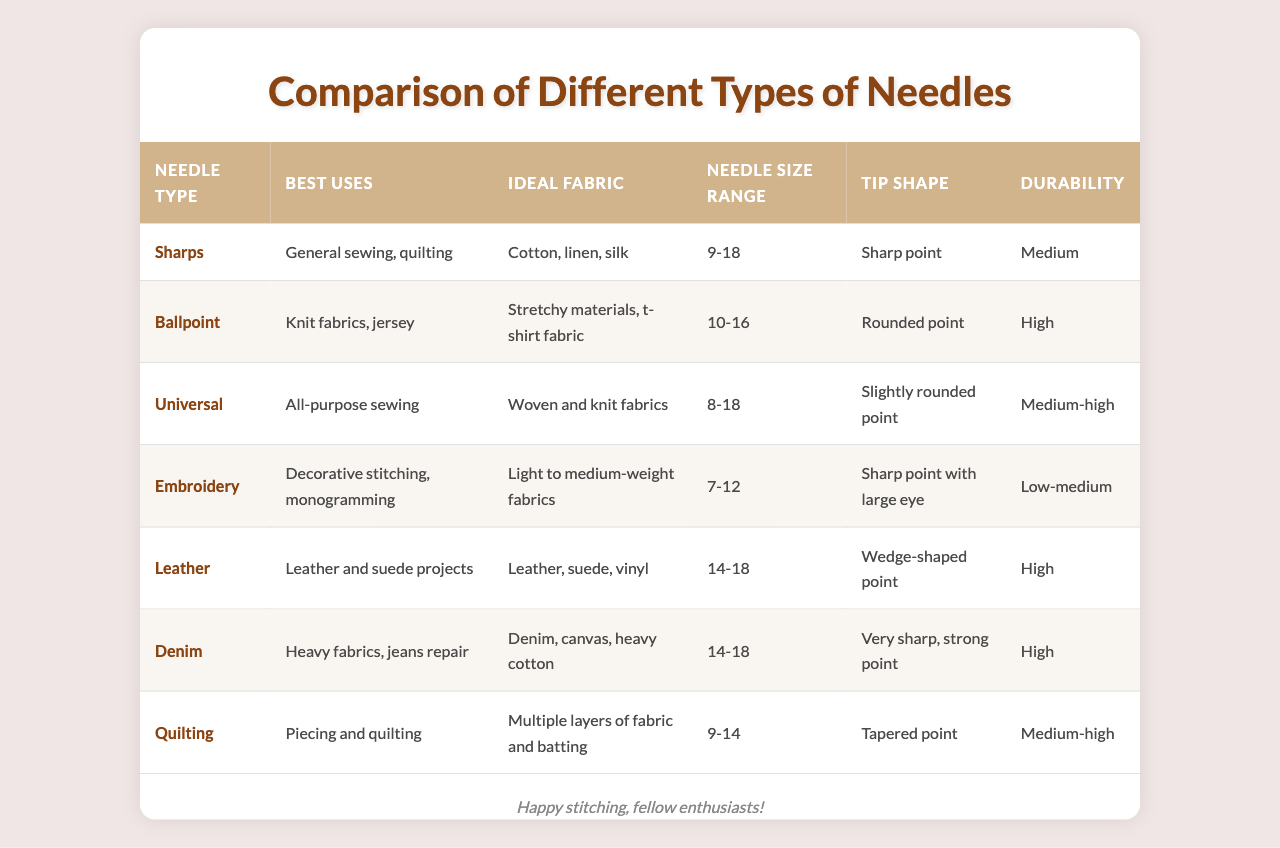What is the best use for ballpoint needles? The table indicates that ballpoint needles are best used for knit fabrics and jersey.
Answer: Knit fabrics, jersey Which needle type has a sharp point and a medium durability? Referring to the table, sharps needles have a sharp point and a medium durability rating.
Answer: Sharps What is the ideal fabric for quilting needles? The table specifies that quilting needles are ideal for multiple layers of fabric and batting.
Answer: Multiple layers of fabric and batting If I want to sew leather, which needle type should I choose? Looking at the best uses listed for needle types, leather needles are designed specifically for leather and suede projects.
Answer: Leather What is the needle size range for embroidery needles? The table provides that embroidery needles have a size range of 7-12.
Answer: 7-12 Is the durability of universal needles higher than that of embroidery needles? The table shows that universal needles have a durability rating of medium-high, while embroidery needles are rated as low-medium, making universal needles more durable.
Answer: Yes How many needle types listed are suitable for heavy fabrics? By checking the table, denim needles and leather needles are specifically indicated for heavy fabrics, showing there are two needle types suitable.
Answer: Two needle types Which needle type is best for decorative stitching and what is its durability? The table reveals that embroidery needles are best for decorative stitching and their durability is rated as low-medium.
Answer: Low-medium What is the average needle size range for all types of needles compared in the table? The average needle size range can be calculated by first finding the size ranges: Sharps (9-18), Ballpoint (10-16), Universal (8-18), Embroidery (7-12), Leather (14-18), Denim (14-18), Quilting (9-14). The ranges can be averaged by finding the midpoint of each range, which simplifies the calculation, leading to an average size range of approximately 10.4-17.2.
Answer: Approximately 10.4-17.2 Which needle type is most durable based on the provided information? The table shows that both ballpoint, leather, and denim needle types are rated as high durability, making them the most durable needle types listed.
Answer: Ballpoint, Leather, Denim 